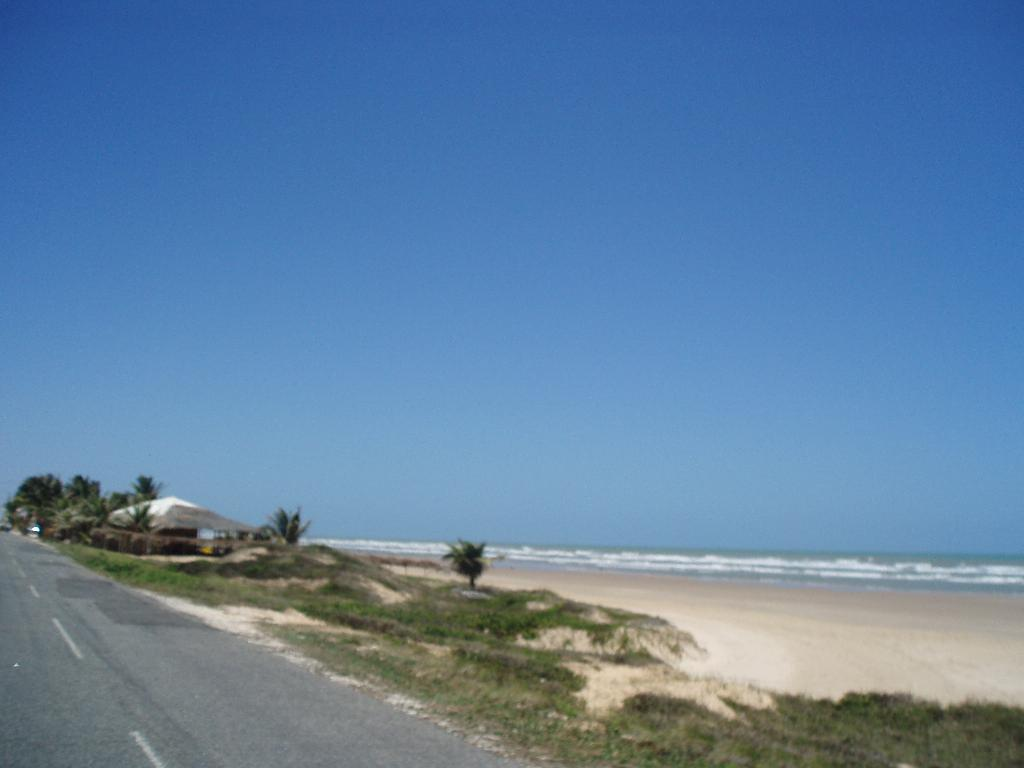What type of vegetation can be seen in the image? There are trees in the image. What type of structure is present in the image? There is a house in the image. What type of ground cover is visible in the image? There is grass in the image. What natural feature can be seen in the image? There is water visible in the image. What color is the sky in the image? The sky is blue in the image. Can you see a mask being worn by anyone in the image? There is no mention of a mask or anyone wearing a mask in the image. What type of musical instrument is being played in the image? There is no mention of a musical instrument or anyone playing one in the image. 